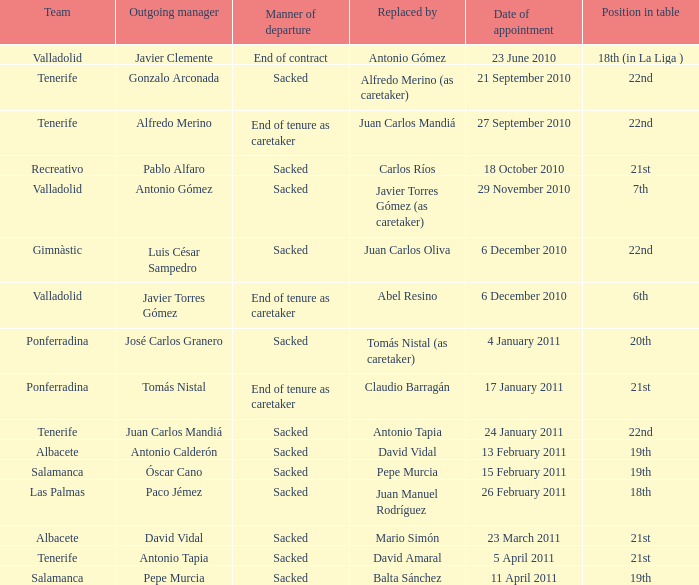When was the appointment date for the leaving manager luis césar sampedro? 6 December 2010. 